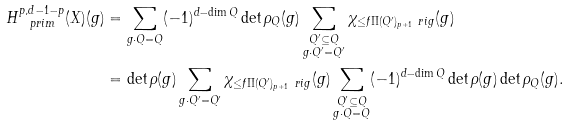Convert formula to latex. <formula><loc_0><loc_0><loc_500><loc_500>H ^ { p , d - 1 - p } _ { \ p r i m } ( X ) ( g ) & = \sum _ { g \cdot Q = Q } ( - 1 ) ^ { d - \dim Q } \det \rho _ { Q } ( g ) \sum _ { \substack { Q ^ { \prime } \subseteq Q \\ g \cdot Q ^ { \prime } = Q ^ { \prime } } } \chi _ { \leq f \Pi ( Q ^ { \prime } ) _ { p + 1 } \ r i g } ( g ) \\ & = \det \rho ( g ) \sum _ { g \cdot Q ^ { \prime } = Q ^ { \prime } } \chi _ { \leq f \Pi ( Q ^ { \prime } ) _ { p + 1 } \ r i g } ( g ) \sum _ { \substack { Q ^ { \prime } \subseteq Q \\ g \cdot Q = Q } } ( - 1 ) ^ { d - \dim Q } \det \rho ( g ) \det \rho _ { Q } ( g ) .</formula> 